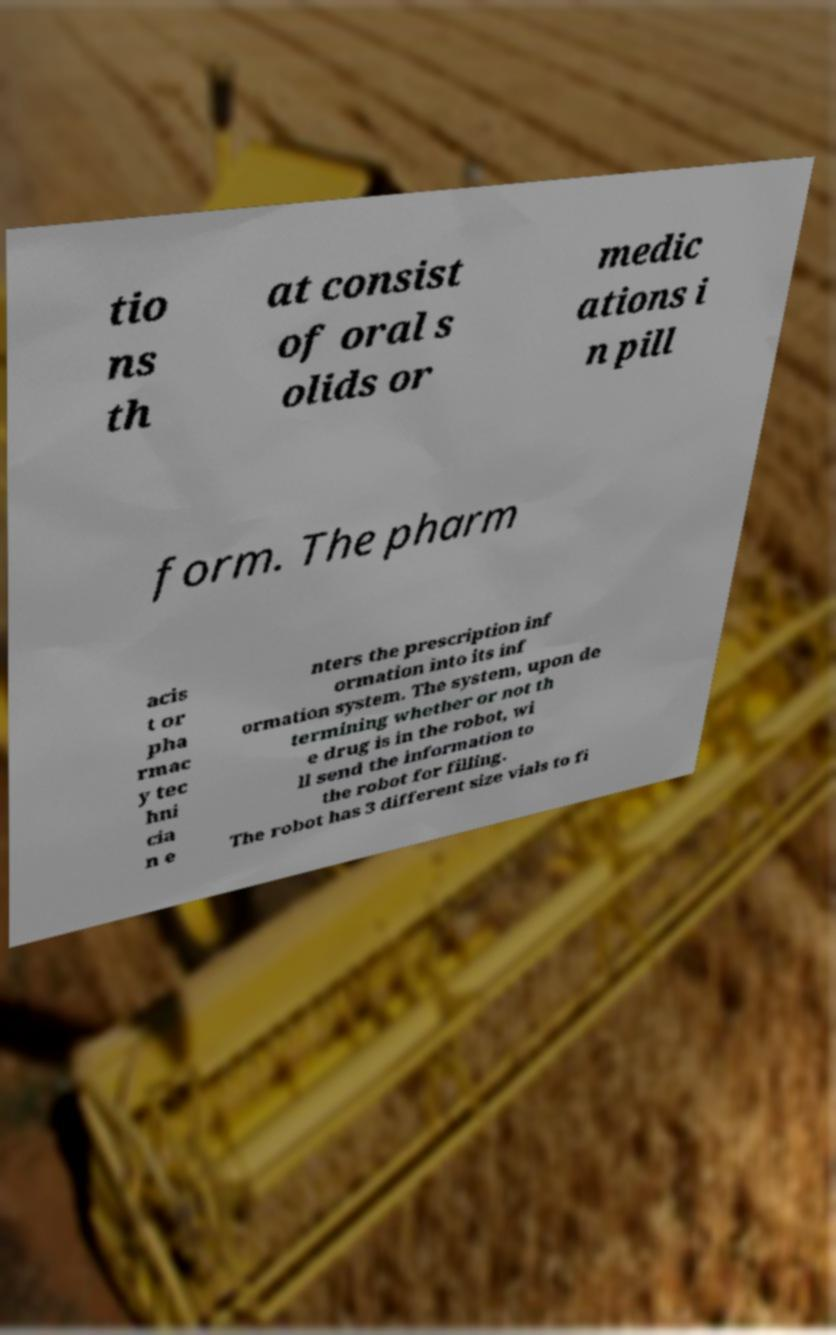Can you accurately transcribe the text from the provided image for me? tio ns th at consist of oral s olids or medic ations i n pill form. The pharm acis t or pha rmac y tec hni cia n e nters the prescription inf ormation into its inf ormation system. The system, upon de termining whether or not th e drug is in the robot, wi ll send the information to the robot for filling. The robot has 3 different size vials to fi 